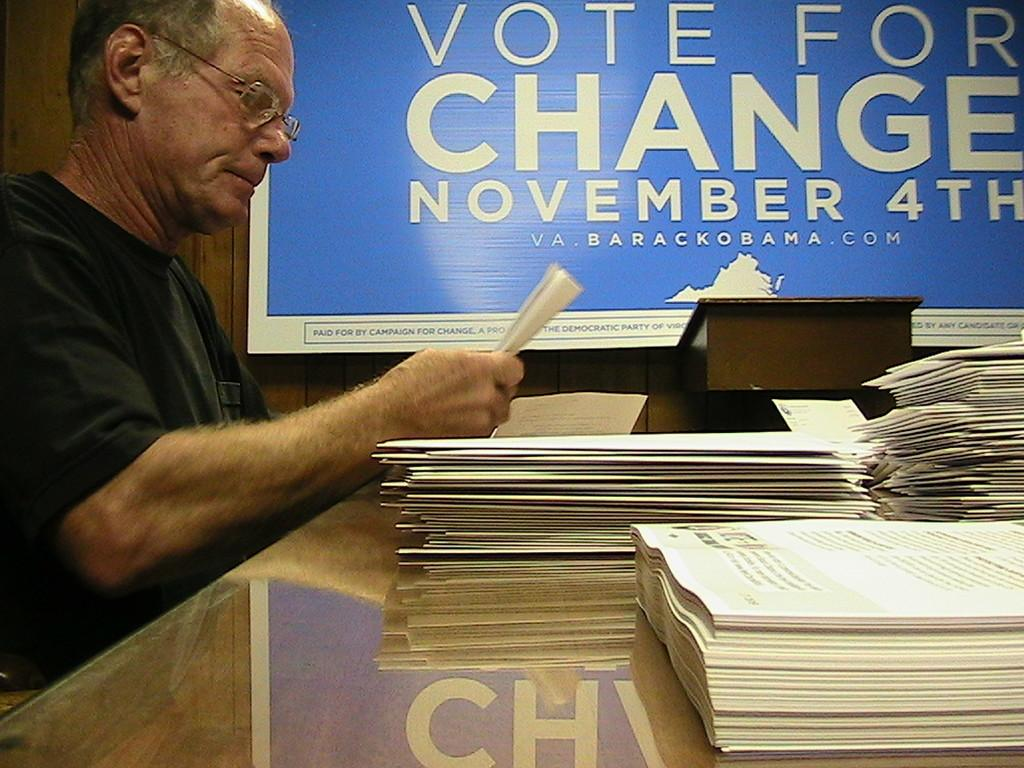<image>
Present a compact description of the photo's key features. A man is seated at a table with papers in his hands related to Barack Obama's campaign. 